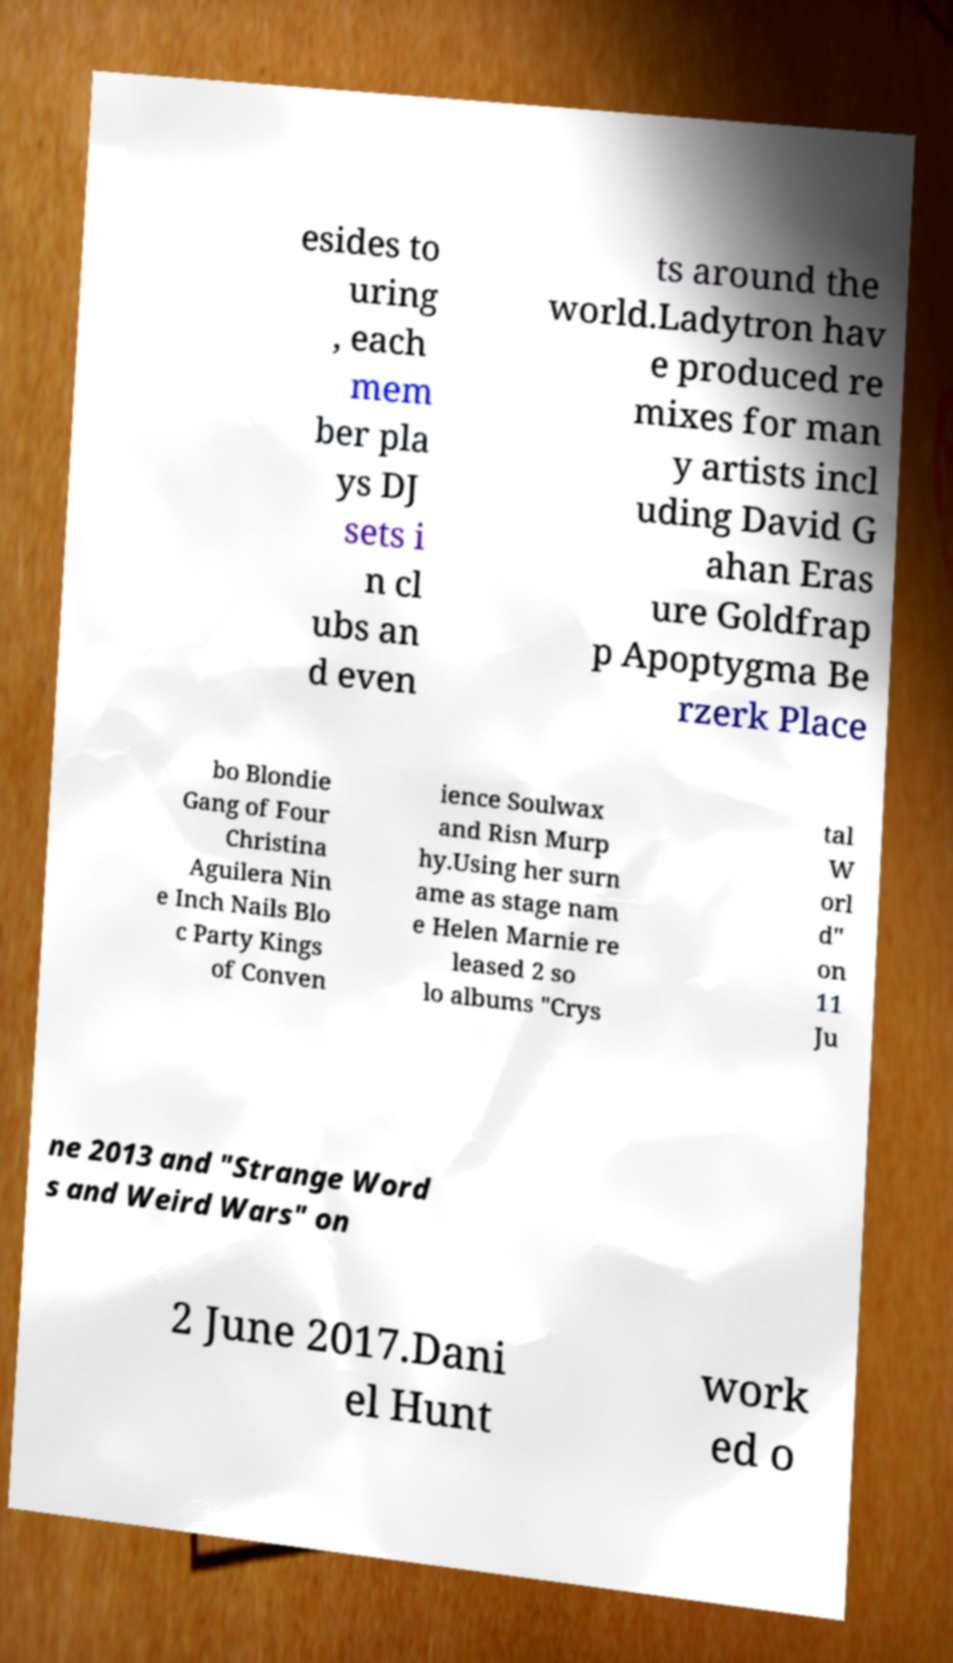Please identify and transcribe the text found in this image. esides to uring , each mem ber pla ys DJ sets i n cl ubs an d even ts around the world.Ladytron hav e produced re mixes for man y artists incl uding David G ahan Eras ure Goldfrap p Apoptygma Be rzerk Place bo Blondie Gang of Four Christina Aguilera Nin e Inch Nails Blo c Party Kings of Conven ience Soulwax and Risn Murp hy.Using her surn ame as stage nam e Helen Marnie re leased 2 so lo albums "Crys tal W orl d" on 11 Ju ne 2013 and "Strange Word s and Weird Wars" on 2 June 2017.Dani el Hunt work ed o 